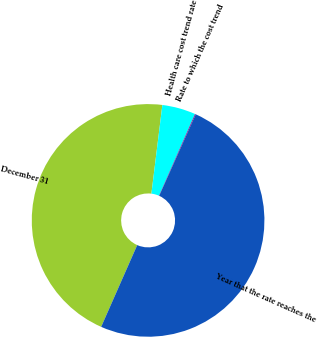Convert chart. <chart><loc_0><loc_0><loc_500><loc_500><pie_chart><fcel>December 31<fcel>Health care cost trend rate<fcel>Rate to which the cost trend<fcel>Year that the rate reaches the<nl><fcel>45.35%<fcel>4.65%<fcel>0.11%<fcel>49.89%<nl></chart> 